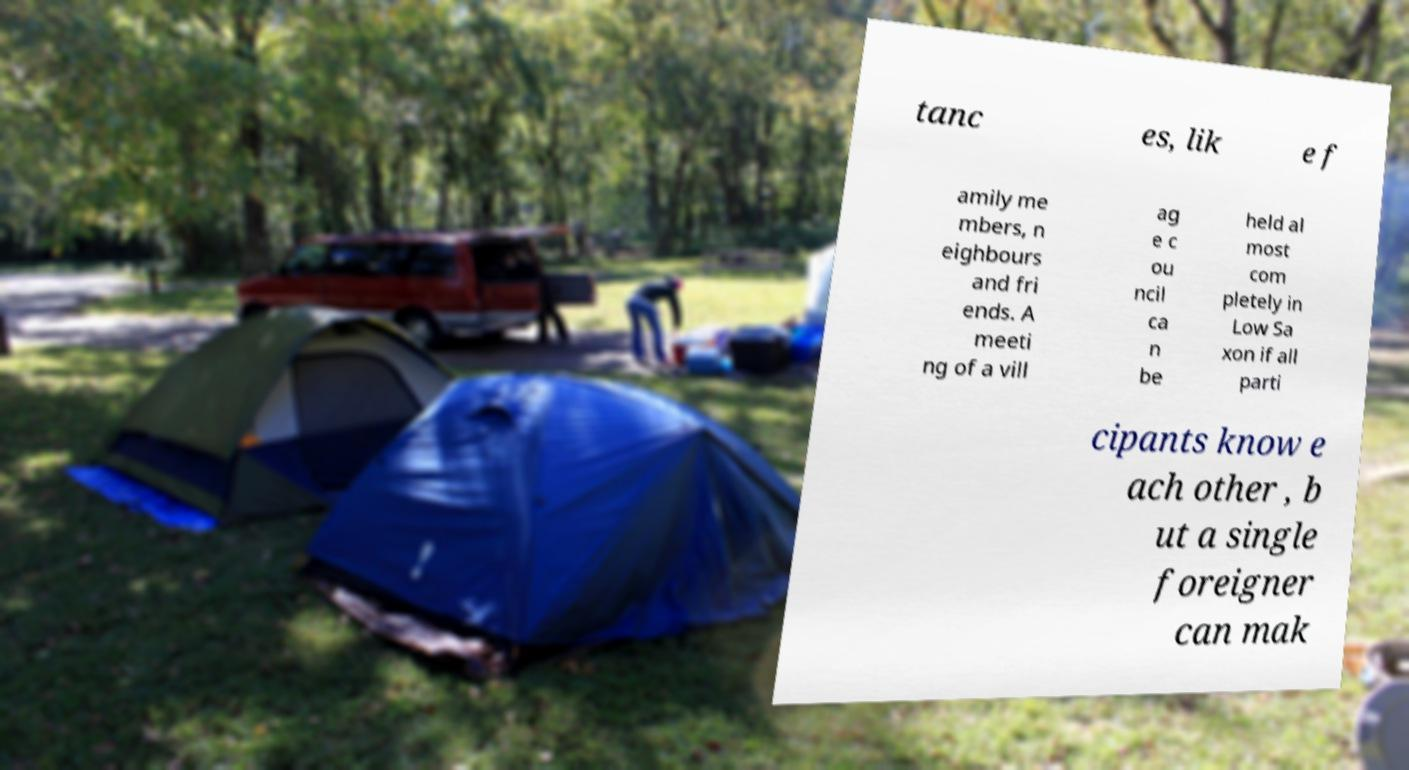Could you assist in decoding the text presented in this image and type it out clearly? tanc es, lik e f amily me mbers, n eighbours and fri ends. A meeti ng of a vill ag e c ou ncil ca n be held al most com pletely in Low Sa xon if all parti cipants know e ach other , b ut a single foreigner can mak 